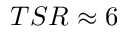<formula> <loc_0><loc_0><loc_500><loc_500>T S R \approx 6</formula> 